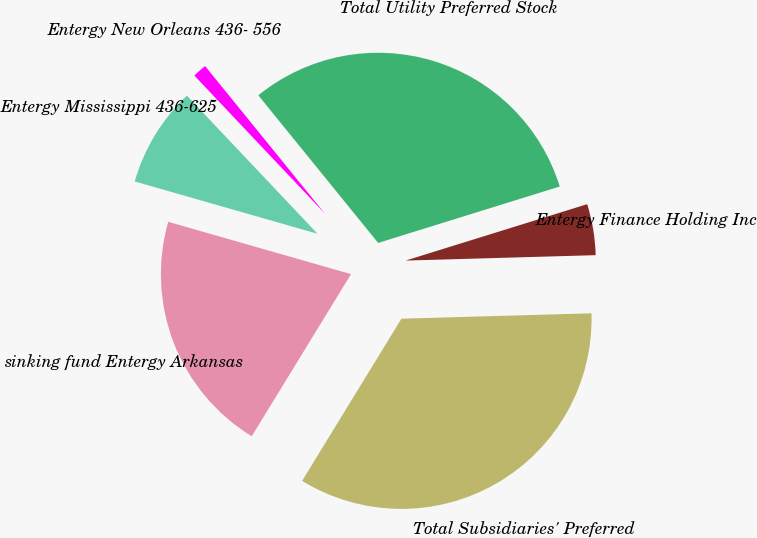Convert chart. <chart><loc_0><loc_0><loc_500><loc_500><pie_chart><fcel>sinking fund Entergy Arkansas<fcel>Entergy Mississippi 436-625<fcel>Entergy New Orleans 436- 556<fcel>Total Utility Preferred Stock<fcel>Entergy Finance Holding Inc<fcel>Total Subsidiaries' Preferred<nl><fcel>20.69%<fcel>8.51%<fcel>1.2%<fcel>31.06%<fcel>4.34%<fcel>34.2%<nl></chart> 